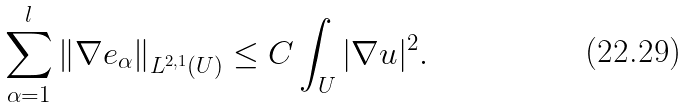<formula> <loc_0><loc_0><loc_500><loc_500>\sum _ { \alpha = 1 } ^ { l } \left \| \nabla e _ { \alpha } \right \| _ { L ^ { 2 , 1 } ( U ) } \leq C \int _ { U } | \nabla u | ^ { 2 } .</formula> 